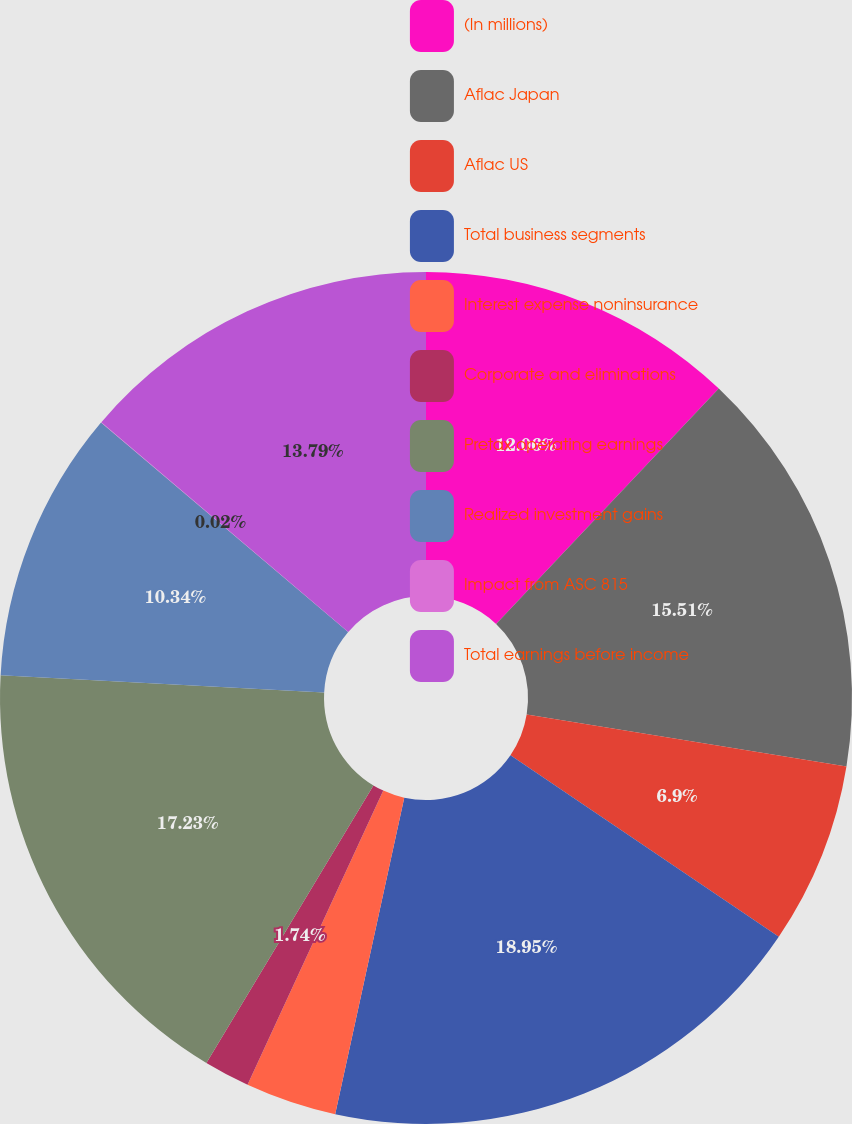Convert chart to OTSL. <chart><loc_0><loc_0><loc_500><loc_500><pie_chart><fcel>(In millions)<fcel>Aflac Japan<fcel>Aflac US<fcel>Total business segments<fcel>Interest expense noninsurance<fcel>Corporate and eliminations<fcel>Pretax operating earnings<fcel>Realized investment gains<fcel>Impact from ASC 815<fcel>Total earnings before income<nl><fcel>12.06%<fcel>15.51%<fcel>6.9%<fcel>18.95%<fcel>3.46%<fcel>1.74%<fcel>17.23%<fcel>10.34%<fcel>0.02%<fcel>13.79%<nl></chart> 